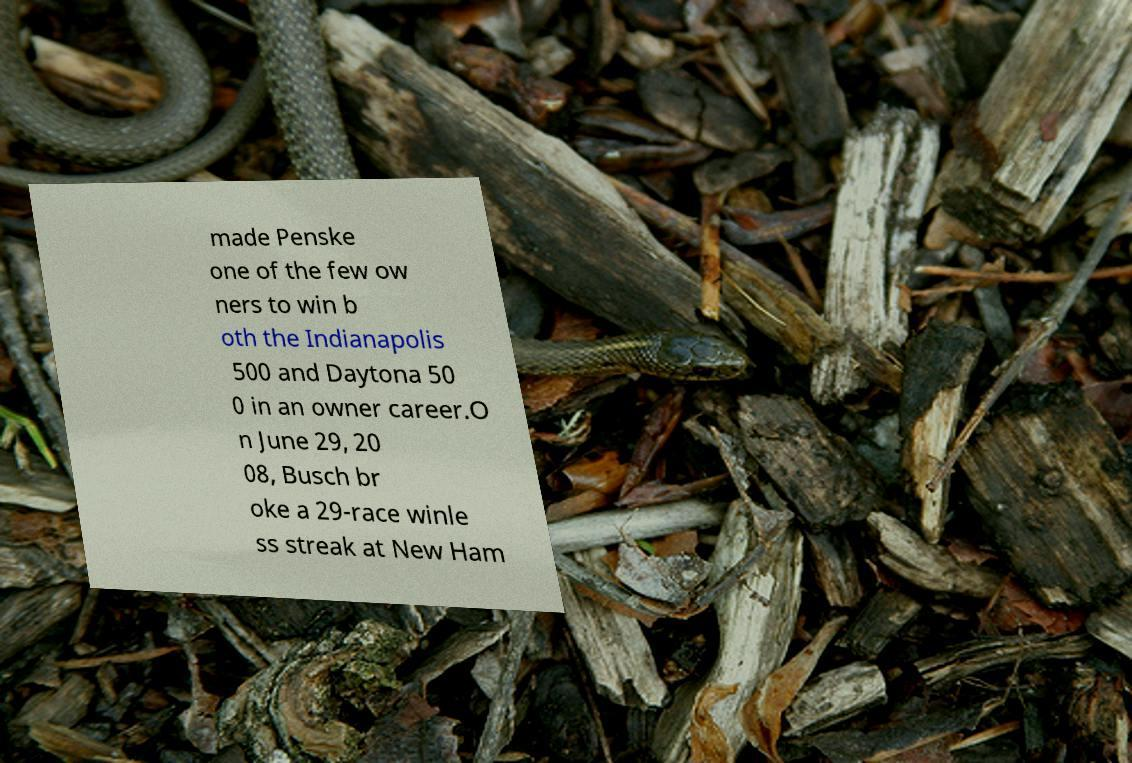There's text embedded in this image that I need extracted. Can you transcribe it verbatim? made Penske one of the few ow ners to win b oth the Indianapolis 500 and Daytona 50 0 in an owner career.O n June 29, 20 08, Busch br oke a 29-race winle ss streak at New Ham 